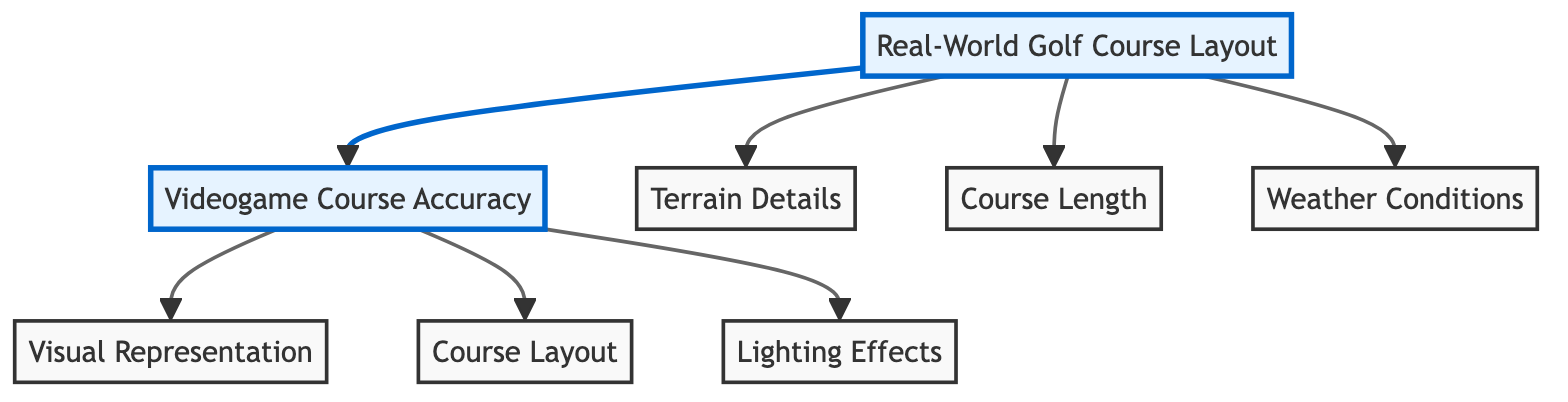What are the two main categories in the diagram? The diagram displays two main categories: Real-World Golf Course Layout and Videogame Course Accuracy, which are the primary nodes represented at the top level.
Answer: Real-World Golf Course Layout; Videogame Course Accuracy How many nodes are linked to Real-World Golf Course Layout? The node Real-World Golf Course Layout is connected to three distinct nodes: Terrain Details, Course Length, and Weather Conditions, thus showing a total of three linked nodes.
Answer: 3 What is the focus of the Videogame Course Accuracy node? The Videogame Course Accuracy node branches into three aspects: Visual Representation, Course Layout, and Lighting Effects, emphasizing these elements as essential for accuracy in golf video games.
Answer: Visual Representation; Course Layout; Lighting Effects Which node emphasizes the impact of environmental factors? The Weather Conditions node under Real-World Golf Course Layout addresses environmental factors affecting golf play, highlighting their significance for a realistic experience.
Answer: Weather Conditions What relationship exists between Real-World Golf Course Layout and Videogame Course Accuracy? The diagram shows a directional relationship where Real-World Golf Course Layout influences Videogame Course Accuracy, indicating a direct connection between real-world features and their game representation.
Answer: Influences 